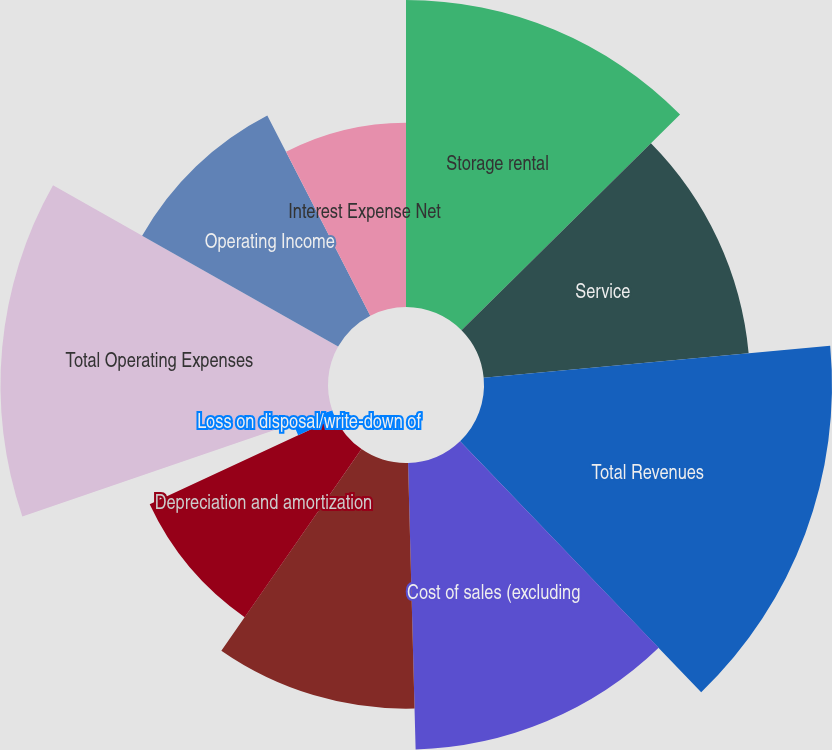Convert chart to OTSL. <chart><loc_0><loc_0><loc_500><loc_500><pie_chart><fcel>Storage rental<fcel>Service<fcel>Total Revenues<fcel>Cost of sales (excluding<fcel>Selling general and<fcel>Depreciation and amortization<fcel>Loss on disposal/write-down of<fcel>Total Operating Expenses<fcel>Operating Income<fcel>Interest Expense Net<nl><fcel>12.6%<fcel>10.92%<fcel>14.28%<fcel>11.76%<fcel>10.08%<fcel>8.4%<fcel>1.68%<fcel>13.44%<fcel>9.24%<fcel>7.56%<nl></chart> 